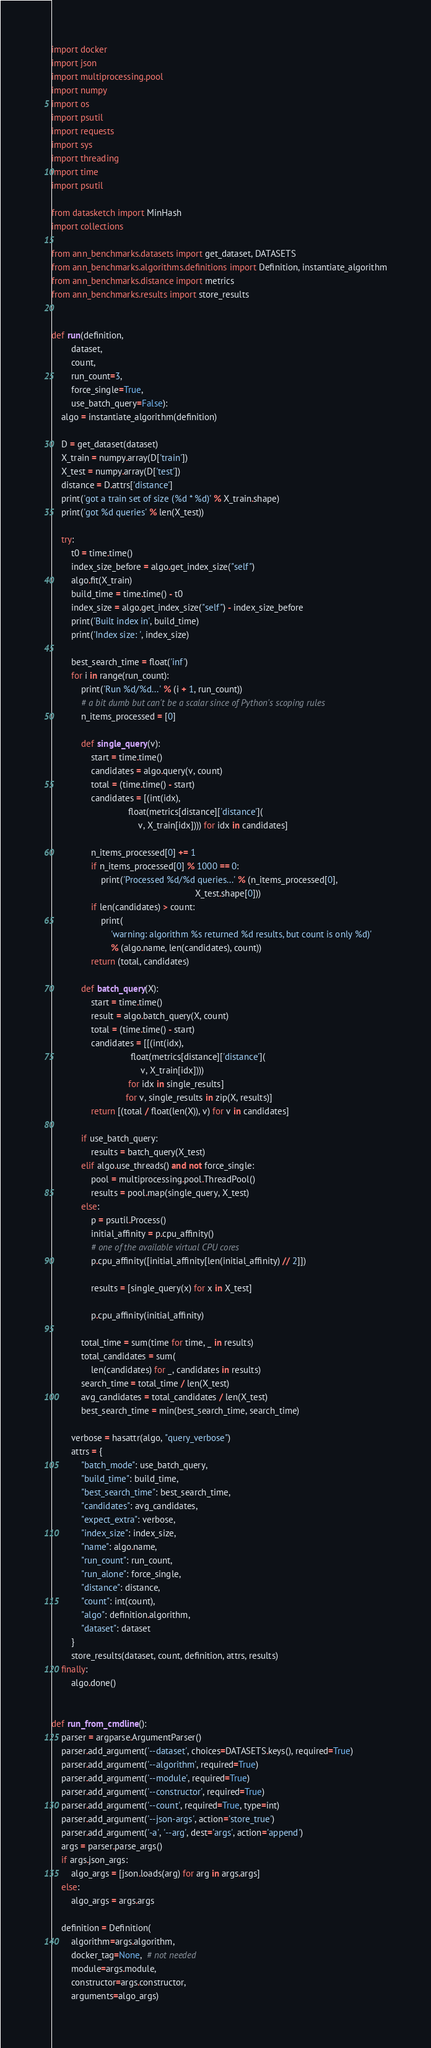Convert code to text. <code><loc_0><loc_0><loc_500><loc_500><_Python_>import docker
import json
import multiprocessing.pool
import numpy
import os
import psutil
import requests
import sys
import threading
import time
import psutil

from datasketch import MinHash
import collections

from ann_benchmarks.datasets import get_dataset, DATASETS
from ann_benchmarks.algorithms.definitions import Definition, instantiate_algorithm
from ann_benchmarks.distance import metrics
from ann_benchmarks.results import store_results


def run(definition,
        dataset,
        count,
        run_count=3,
        force_single=True,
        use_batch_query=False):
    algo = instantiate_algorithm(definition)

    D = get_dataset(dataset)
    X_train = numpy.array(D['train'])
    X_test = numpy.array(D['test'])
    distance = D.attrs['distance']
    print('got a train set of size (%d * %d)' % X_train.shape)
    print('got %d queries' % len(X_test))

    try:
        t0 = time.time()
        index_size_before = algo.get_index_size("self")
        algo.fit(X_train)
        build_time = time.time() - t0
        index_size = algo.get_index_size("self") - index_size_before
        print('Built index in', build_time)
        print('Index size: ', index_size)

        best_search_time = float('inf')
        for i in range(run_count):
            print('Run %d/%d...' % (i + 1, run_count))
            # a bit dumb but can't be a scalar since of Python's scoping rules
            n_items_processed = [0]

            def single_query(v):
                start = time.time()
                candidates = algo.query(v, count)
                total = (time.time() - start)
                candidates = [(int(idx),
                               float(metrics[distance]['distance'](
                                   v, X_train[idx]))) for idx in candidates]

                n_items_processed[0] += 1
                if n_items_processed[0] % 1000 == 0:
                    print('Processed %d/%d queries...' % (n_items_processed[0],
                                                          X_test.shape[0]))
                if len(candidates) > count:
                    print(
                        'warning: algorithm %s returned %d results, but count is only %d)'
                        % (algo.name, len(candidates), count))
                return (total, candidates)

            def batch_query(X):
                start = time.time()
                result = algo.batch_query(X, count)
                total = (time.time() - start)
                candidates = [[(int(idx),
                                float(metrics[distance]['distance'](
                                    v, X_train[idx])))
                               for idx in single_results]
                              for v, single_results in zip(X, results)]
                return [(total / float(len(X)), v) for v in candidates]

            if use_batch_query:
                results = batch_query(X_test)
            elif algo.use_threads() and not force_single:
                pool = multiprocessing.pool.ThreadPool()
                results = pool.map(single_query, X_test)
            else:
                p = psutil.Process()
                initial_affinity = p.cpu_affinity()
                # one of the available virtual CPU cores
                p.cpu_affinity([initial_affinity[len(initial_affinity) // 2]])

                results = [single_query(x) for x in X_test]

                p.cpu_affinity(initial_affinity)

            total_time = sum(time for time, _ in results)
            total_candidates = sum(
                len(candidates) for _, candidates in results)
            search_time = total_time / len(X_test)
            avg_candidates = total_candidates / len(X_test)
            best_search_time = min(best_search_time, search_time)

        verbose = hasattr(algo, "query_verbose")
        attrs = {
            "batch_mode": use_batch_query,
            "build_time": build_time,
            "best_search_time": best_search_time,
            "candidates": avg_candidates,
            "expect_extra": verbose,
            "index_size": index_size,
            "name": algo.name,
            "run_count": run_count,
            "run_alone": force_single,
            "distance": distance,
            "count": int(count),
            "algo": definition.algorithm,
            "dataset": dataset
        }
        store_results(dataset, count, definition, attrs, results)
    finally:
        algo.done()


def run_from_cmdline():
    parser = argparse.ArgumentParser()
    parser.add_argument('--dataset', choices=DATASETS.keys(), required=True)
    parser.add_argument('--algorithm', required=True)
    parser.add_argument('--module', required=True)
    parser.add_argument('--constructor', required=True)
    parser.add_argument('--count', required=True, type=int)
    parser.add_argument('--json-args', action='store_true')
    parser.add_argument('-a', '--arg', dest='args', action='append')
    args = parser.parse_args()
    if args.json_args:
        algo_args = [json.loads(arg) for arg in args.args]
    else:
        algo_args = args.args

    definition = Definition(
        algorithm=args.algorithm,
        docker_tag=None,  # not needed
        module=args.module,
        constructor=args.constructor,
        arguments=algo_args)</code> 